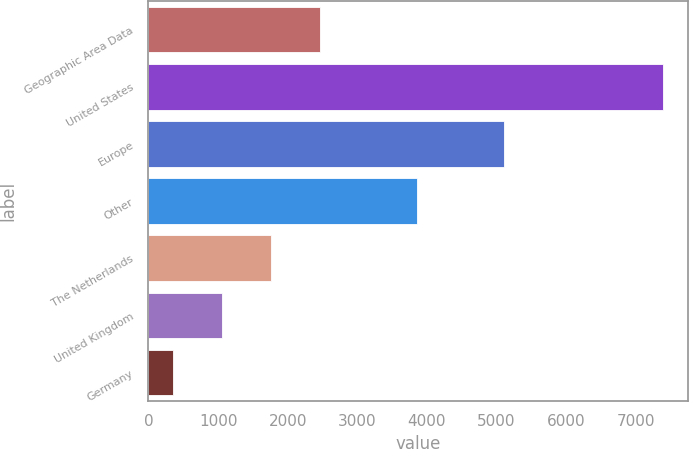Convert chart to OTSL. <chart><loc_0><loc_0><loc_500><loc_500><bar_chart><fcel>Geographic Area Data<fcel>United States<fcel>Europe<fcel>Other<fcel>The Netherlands<fcel>United Kingdom<fcel>Germany<nl><fcel>2462.36<fcel>7389.8<fcel>5104<fcel>3861.4<fcel>1758.44<fcel>1054.52<fcel>350.6<nl></chart> 